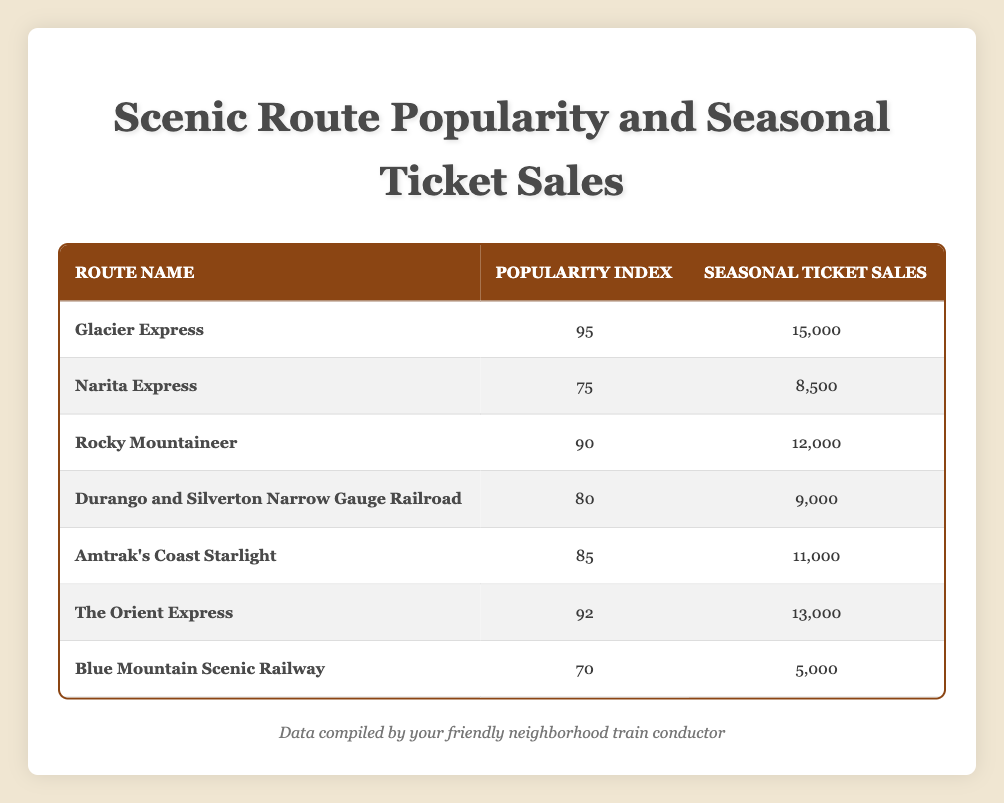What is the popularity index of the Glacier Express? The table shows that the Glacier Express has a popularity index of 95, as indicated in the corresponding row.
Answer: 95 Which route has the highest seasonal ticket sales? By looking at the seasonal ticket sales column, the Glacier Express has the highest sales at 15,000.
Answer: Glacier Express What is the average popularity index of the scenic routes listed? To find the average popularity index, add all the popularity indices: (95 + 75 + 90 + 80 + 85 + 92 + 70) = 687. There are 7 routes, so the average is 687/7 ≈ 98.14.
Answer: 98.14 Is the seasonal ticket sales for the Blue Mountain Scenic Railway greater than 5,000? The table shows that the seasonal ticket sales for the Blue Mountain Scenic Railway is 5,000, which is not greater than 5,000.
Answer: No Which route has the lowest popularity index, and what is its ticket sales amount? The table indicates that the Blue Mountain Scenic Railway has the lowest popularity index at 70, and its seasonal ticket sales are 5,000.
Answer: Blue Mountain Scenic Railway, 5,000 What is the difference in seasonal ticket sales between the Glacier Express and the Rocky Mountaineer? The seasonal ticket sales for the Glacier Express are 15,000 and for the Rocky Mountaineer are 12,000. The difference is 15,000 - 12,000 = 3,000.
Answer: 3,000 How many scenic routes have a popularity index above 80? By reviewing the popularity index column, the routes with an index above 80 are: Glacier Express (95), Rocky Mountaineer (90), Amtrak's Coast Starlight (85), The Orient Express (92), which totals to 4 routes.
Answer: 4 What is the total seasonal ticket sales across all routes? Adding the seasonal ticket sales from all routes gives us: (15,000 + 8,500 + 12,000 + 9,000 + 11,000 + 13,000 + 5,000) = 73,500.
Answer: 73,500 Is the Amtrak's Coast Starlight more popular than the Narita Express based on the given indices? The popularity index for Amtrak's Coast Starlight is 85, while for the Narita Express, it is 75. Therefore, Amtrak's Coast Starlight is more popular.
Answer: Yes 